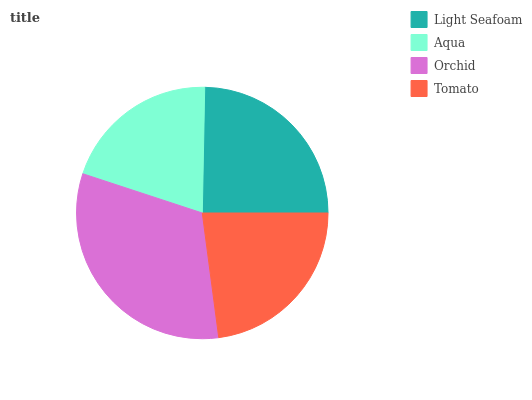Is Aqua the minimum?
Answer yes or no. Yes. Is Orchid the maximum?
Answer yes or no. Yes. Is Orchid the minimum?
Answer yes or no. No. Is Aqua the maximum?
Answer yes or no. No. Is Orchid greater than Aqua?
Answer yes or no. Yes. Is Aqua less than Orchid?
Answer yes or no. Yes. Is Aqua greater than Orchid?
Answer yes or no. No. Is Orchid less than Aqua?
Answer yes or no. No. Is Light Seafoam the high median?
Answer yes or no. Yes. Is Tomato the low median?
Answer yes or no. Yes. Is Orchid the high median?
Answer yes or no. No. Is Orchid the low median?
Answer yes or no. No. 